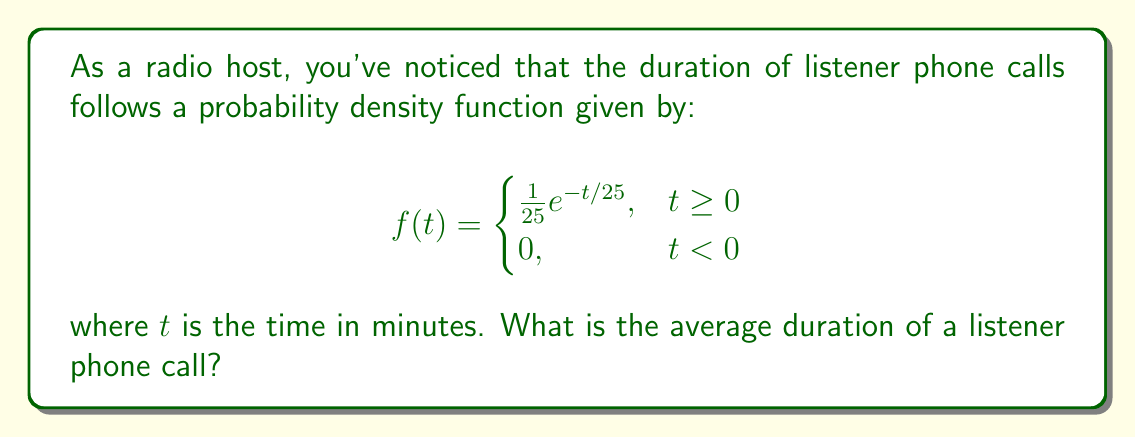Teach me how to tackle this problem. To find the average duration of a listener phone call, we need to calculate the expected value of the random variable $T$ representing the call duration. The expected value is given by:

$$E[T] = \int_{-\infty}^{\infty} t f(t) dt$$

Given our probability density function:

1) We can simplify the integral since $f(t) = 0$ for $t < 0$:

   $$E[T] = \int_{0}^{\infty} t \cdot \frac{1}{25}e^{-t/25} dt$$

2) Let's solve this integral using integration by parts:
   Let $u = t$ and $dv = \frac{1}{25}e^{-t/25} dt$
   Then $du = dt$ and $v = -e^{-t/25}$

   $$E[T] = \left[-te^{-t/25}\right]_{0}^{\infty} + \int_{0}^{\infty} e^{-t/25} dt$$

3) Evaluate the first term:
   $$\lim_{t \to \infty} (-te^{-t/25}) - (-0 \cdot e^{-0/25}) = 0 - 0 = 0$$

4) Solve the remaining integral:
   $$E[T] = \int_{0}^{\infty} e^{-t/25} dt = \left[-25e^{-t/25}\right]_{0}^{\infty} = 0 - (-25) = 25$$

Therefore, the average duration of a listener phone call is 25 minutes.
Answer: 25 minutes 